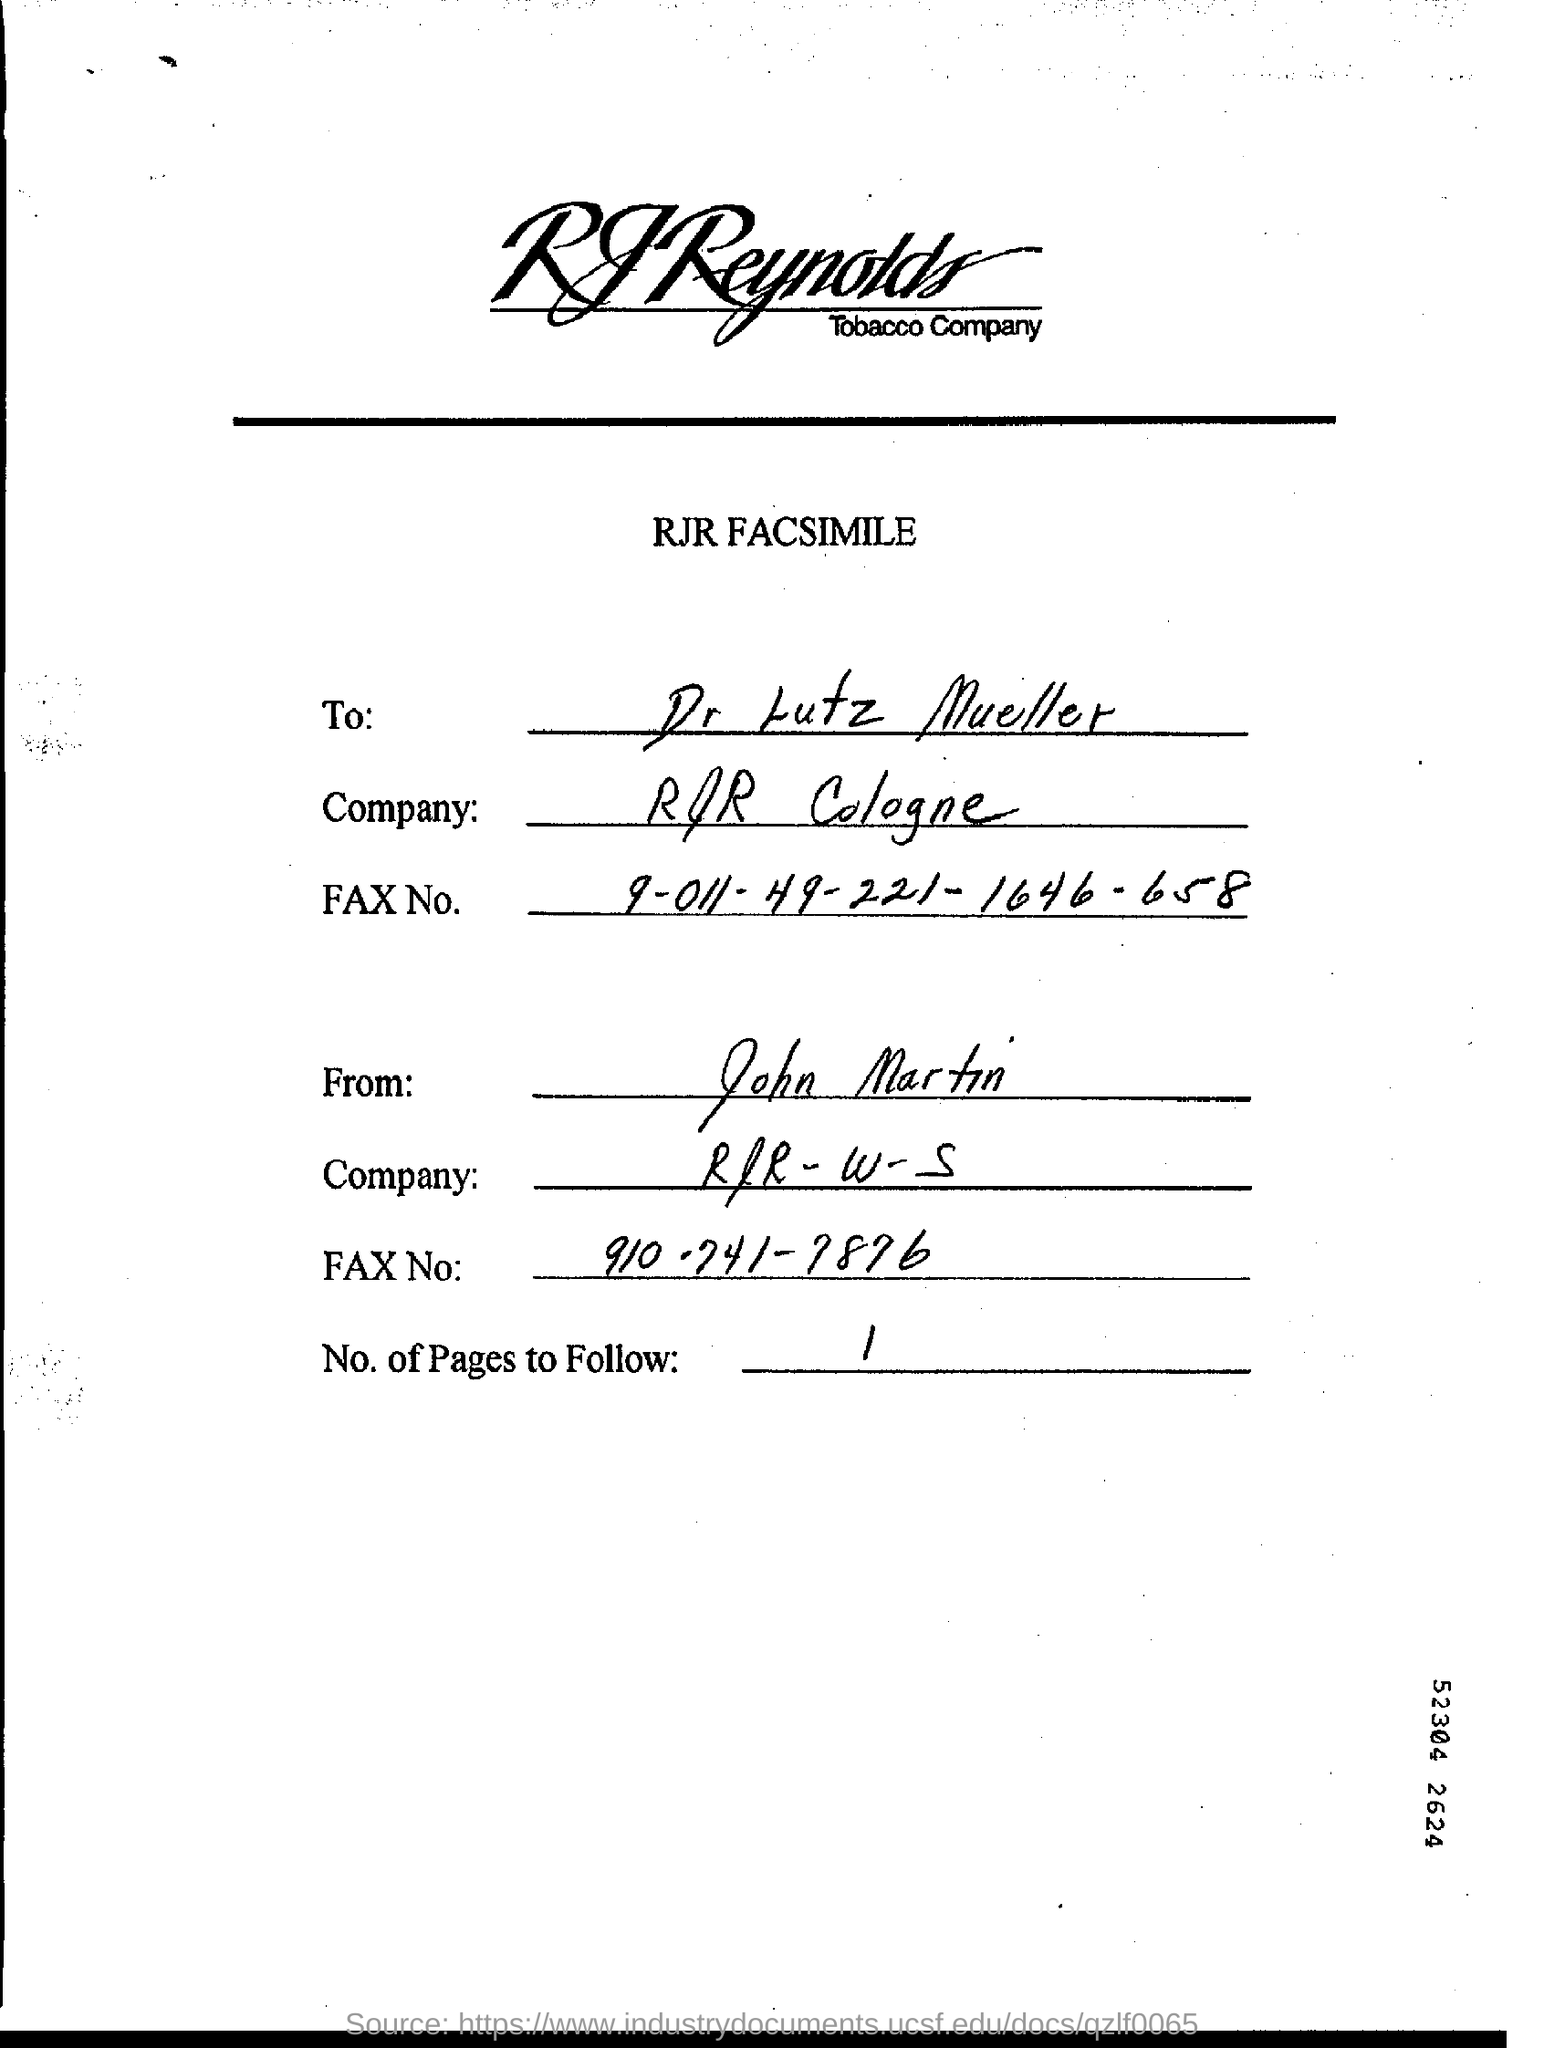Outline some significant characteristics in this image. The letter is from John Martin. There will be one page following this one. The company to which this letter is addressed is RJR Cologne. The letter is addressed to Dr. Lutz Mueller. 